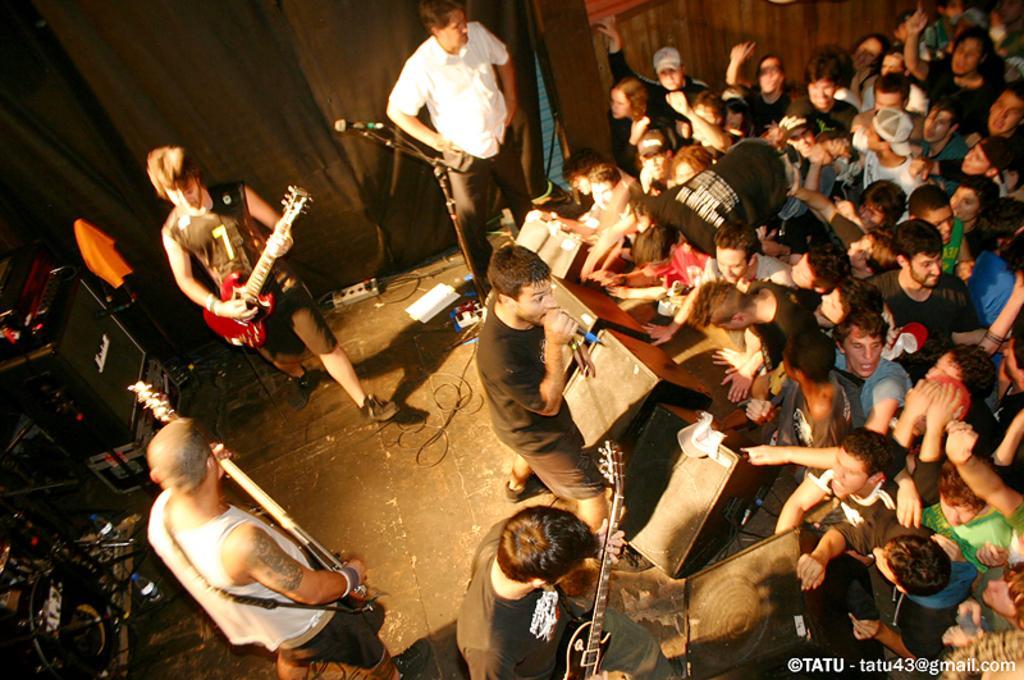How would you summarize this image in a sentence or two? In this image I see number of people, in which these five persons are standing on stage and these 3 are holding guitars and this guys holding the mic. I can also see few equipment over here and these people are standing. 